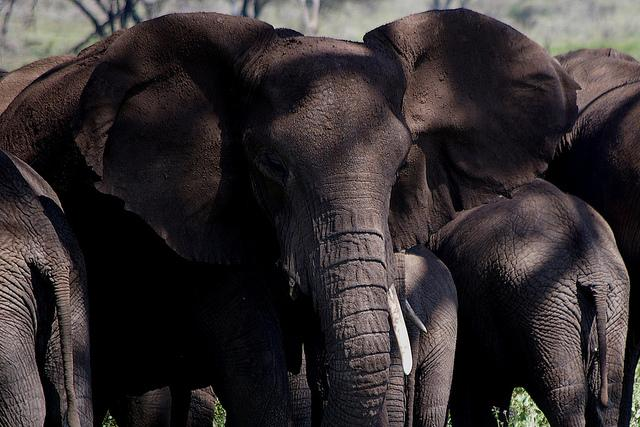What type of elephant is in the image? adult 